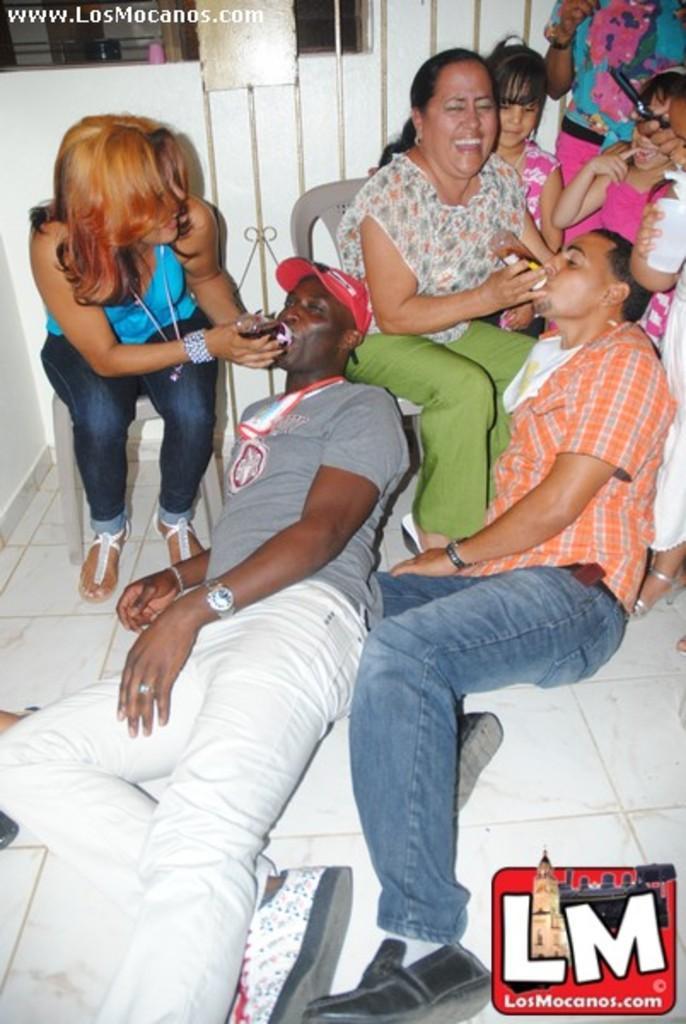In one or two sentences, can you explain what this image depicts? In this picture we can see a group of people,some people are sitting and some people are standing. 